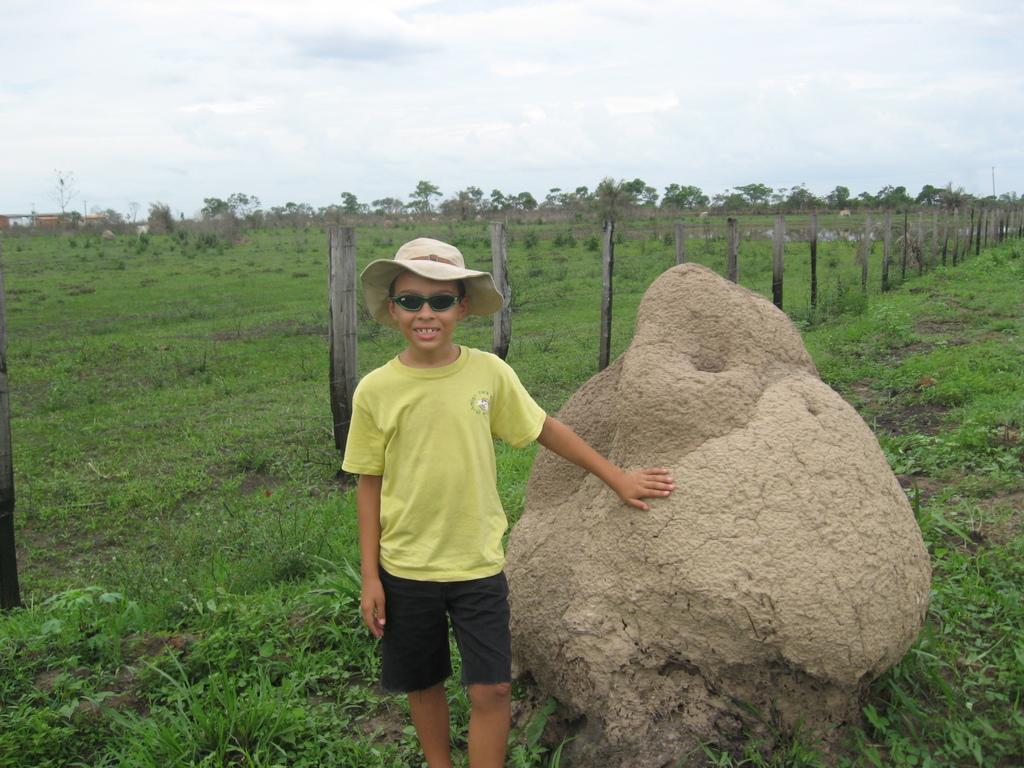In one or two sentences, can you explain what this image depicts? In this image we can see a boy wearing a cap. There is a rock beside him. In the background of the image there are trees, sky, clouds. There is a fencing. At the bottom of the image there is grass and plants. 